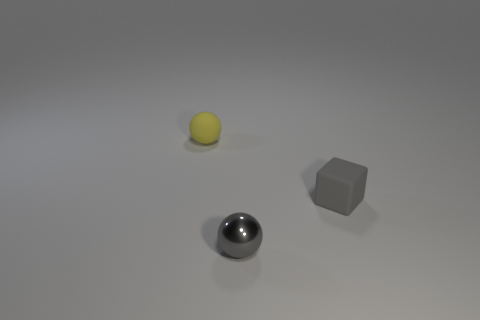Does the small shiny ball have the same color as the tiny block?
Give a very brief answer. Yes. There is a small ball that is the same color as the matte cube; what is it made of?
Offer a very short reply. Metal. Are the gray sphere and the small gray cube made of the same material?
Ensure brevity in your answer.  No. Is there a object that has the same color as the rubber block?
Offer a very short reply. Yes. The small ball right of the tiny sphere that is behind the metal thing is made of what material?
Your answer should be very brief. Metal. Are there an equal number of gray shiny objects that are right of the small block and tiny rubber balls left of the gray metal object?
Provide a succinct answer. No. How many things are spheres that are in front of the yellow object or small spheres that are left of the metallic object?
Your answer should be compact. 2. What material is the thing that is behind the small gray ball and on the right side of the tiny yellow rubber sphere?
Provide a short and direct response. Rubber. Is the number of tiny purple metal cubes greater than the number of tiny gray blocks?
Your answer should be compact. No. Are the tiny sphere that is on the right side of the small yellow rubber thing and the block made of the same material?
Keep it short and to the point. No. 